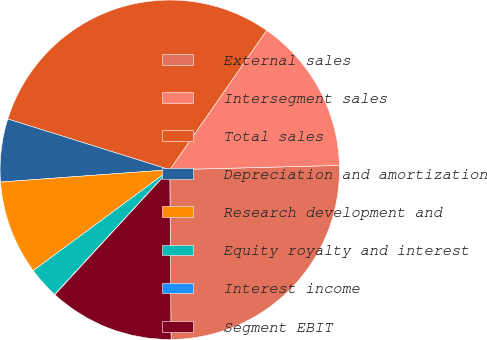Convert chart. <chart><loc_0><loc_0><loc_500><loc_500><pie_chart><fcel>External sales<fcel>Intersegment sales<fcel>Total sales<fcel>Depreciation and amortization<fcel>Research development and<fcel>Equity royalty and interest<fcel>Interest income<fcel>Segment EBIT<nl><fcel>25.29%<fcel>14.93%<fcel>29.83%<fcel>5.99%<fcel>8.97%<fcel>3.01%<fcel>0.03%<fcel>11.95%<nl></chart> 